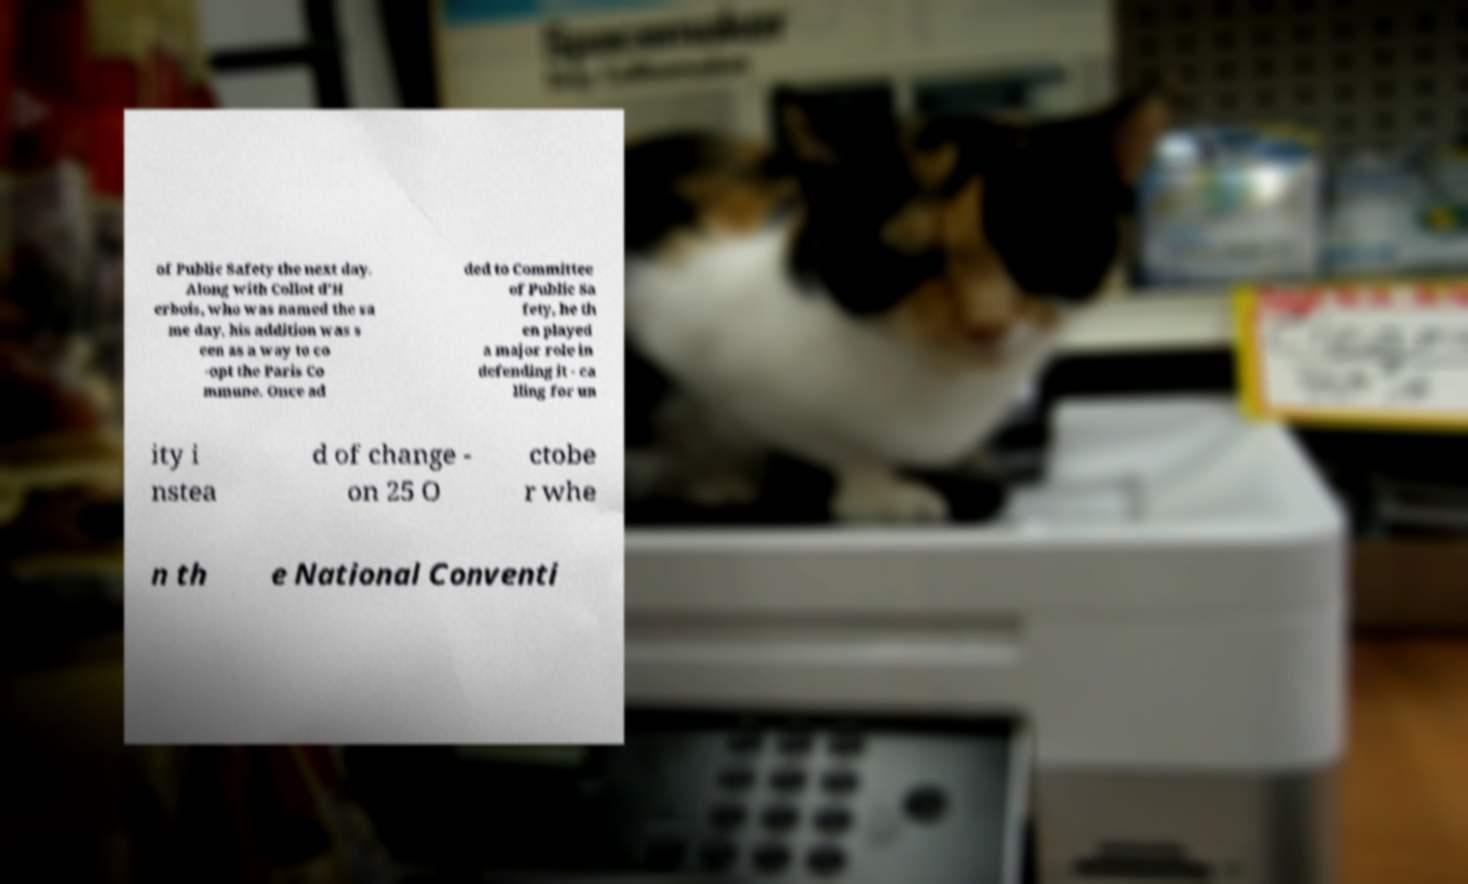There's text embedded in this image that I need extracted. Can you transcribe it verbatim? of Public Safety the next day. Along with Collot d'H erbois, who was named the sa me day, his addition was s een as a way to co -opt the Paris Co mmune. Once ad ded to Committee of Public Sa fety, he th en played a major role in defending it - ca lling for un ity i nstea d of change - on 25 O ctobe r whe n th e National Conventi 